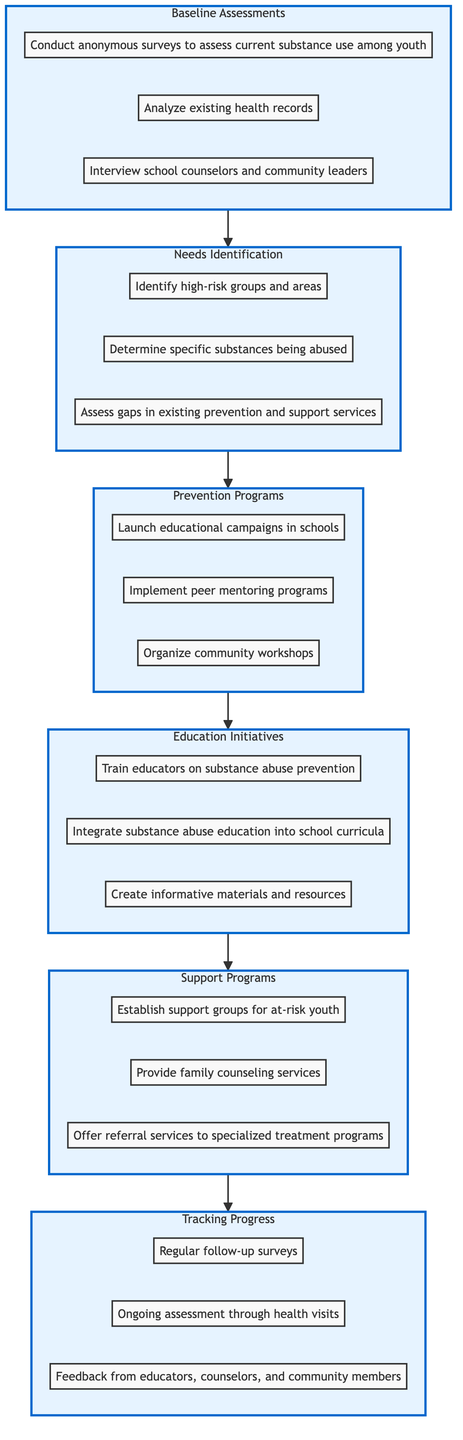What is the top level of the flow chart? The flow chart is structured with levels, and the top level is designated as "Tracking Progress," which is the final outcome of the diagram's flow.
Answer: Tracking Progress How many elements are in the "Support Programs" level? The "Support Programs" level consists of three distinct elements, namely establishing support groups, providing family counseling services, and offering referral services.
Answer: 3 Which level comes directly before "Education Initiatives"? In the flow chart, "Prevention Programs" is the level that directly precedes "Education Initiatives," indicating that prevention activities occur prior to educational efforts.
Answer: Prevention Programs What type of assessments are included in the "Baseline Assessments" level? The "Baseline Assessments" level includes three types of assessments: anonymous surveys, analysis of health records, and interviews with school counselors and community leaders, which are aimed at determining the current state of substance use among youth.
Answer: Anonymous surveys, analysis of health records, interviews Which level addresses the identification of high-risk groups? The level dedicated to identifying high-risk groups is called "Needs Identification," which focuses on determining specific substances being abused and assessing gaps in existing services as well.
Answer: Needs Identification How many total levels are present in the flow chart? The flow chart includes a total of six distinct levels that outline the steps to build a substance abuse-free youth program from assessment to tracking progress.
Answer: 6 What is the relationship between "Prevention Programs" and "Support Programs"? "Prevention Programs" lead to "Education Initiatives," which subsequently influence "Support Programs," indicating a sequential relationship where prevention strategies pave the way for educational initiatives before establishing support services.
Answer: Sequential relationship What is the purpose of "Tracking Progress"? The purpose of "Tracking Progress" is to evaluate the effectiveness of the implemented programs through regular follow-up surveys, health visits, and feedback mechanisms, ensuring continual assessment and adjustment of strategies.
Answer: Evaluate effectiveness What element helps provide family counseling services in the flow chart? "Support Programs" represents the level that encompasses providing family counseling services aimed at supporting families affected by substance use issues among youth.
Answer: Support Programs 